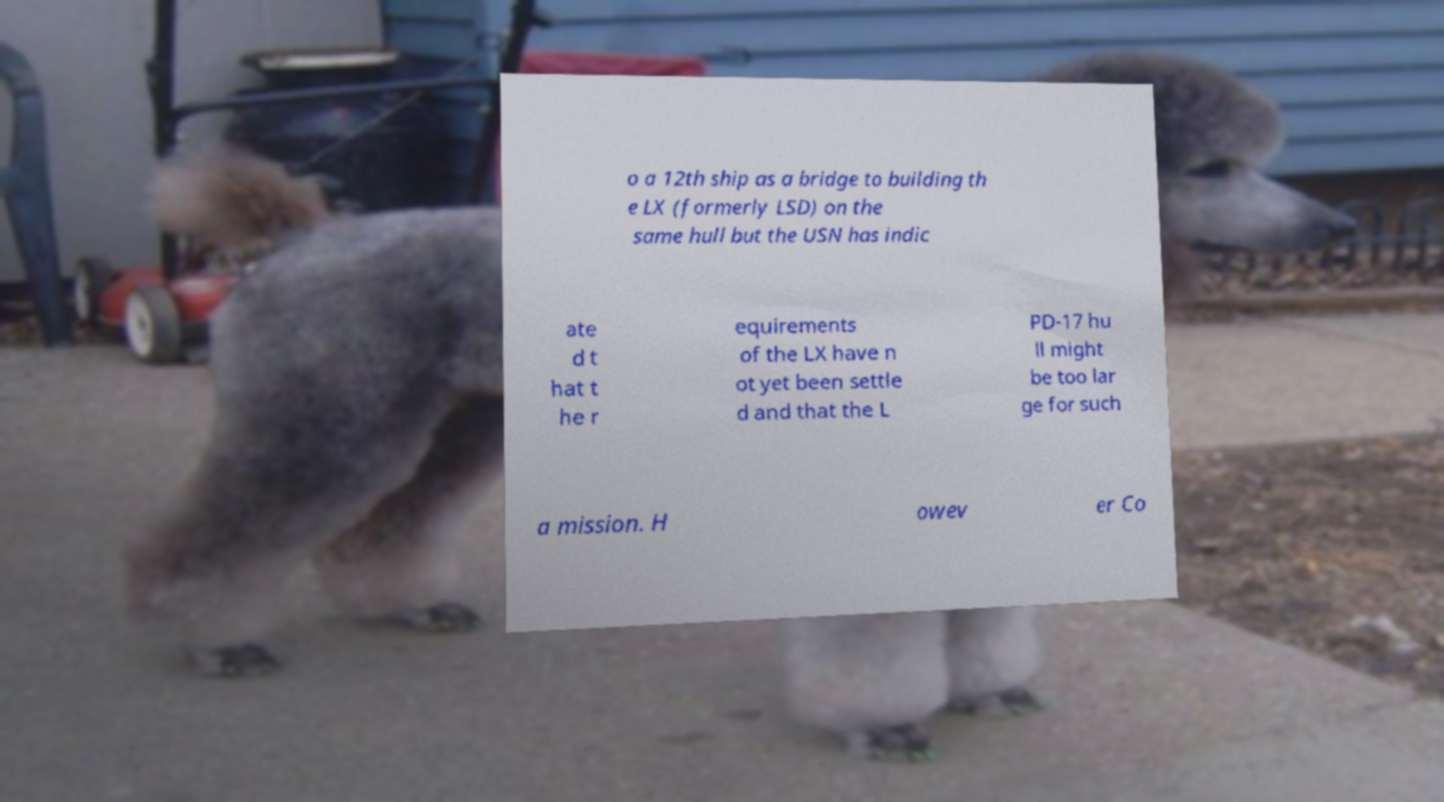Please identify and transcribe the text found in this image. o a 12th ship as a bridge to building th e LX (formerly LSD) on the same hull but the USN has indic ate d t hat t he r equirements of the LX have n ot yet been settle d and that the L PD-17 hu ll might be too lar ge for such a mission. H owev er Co 